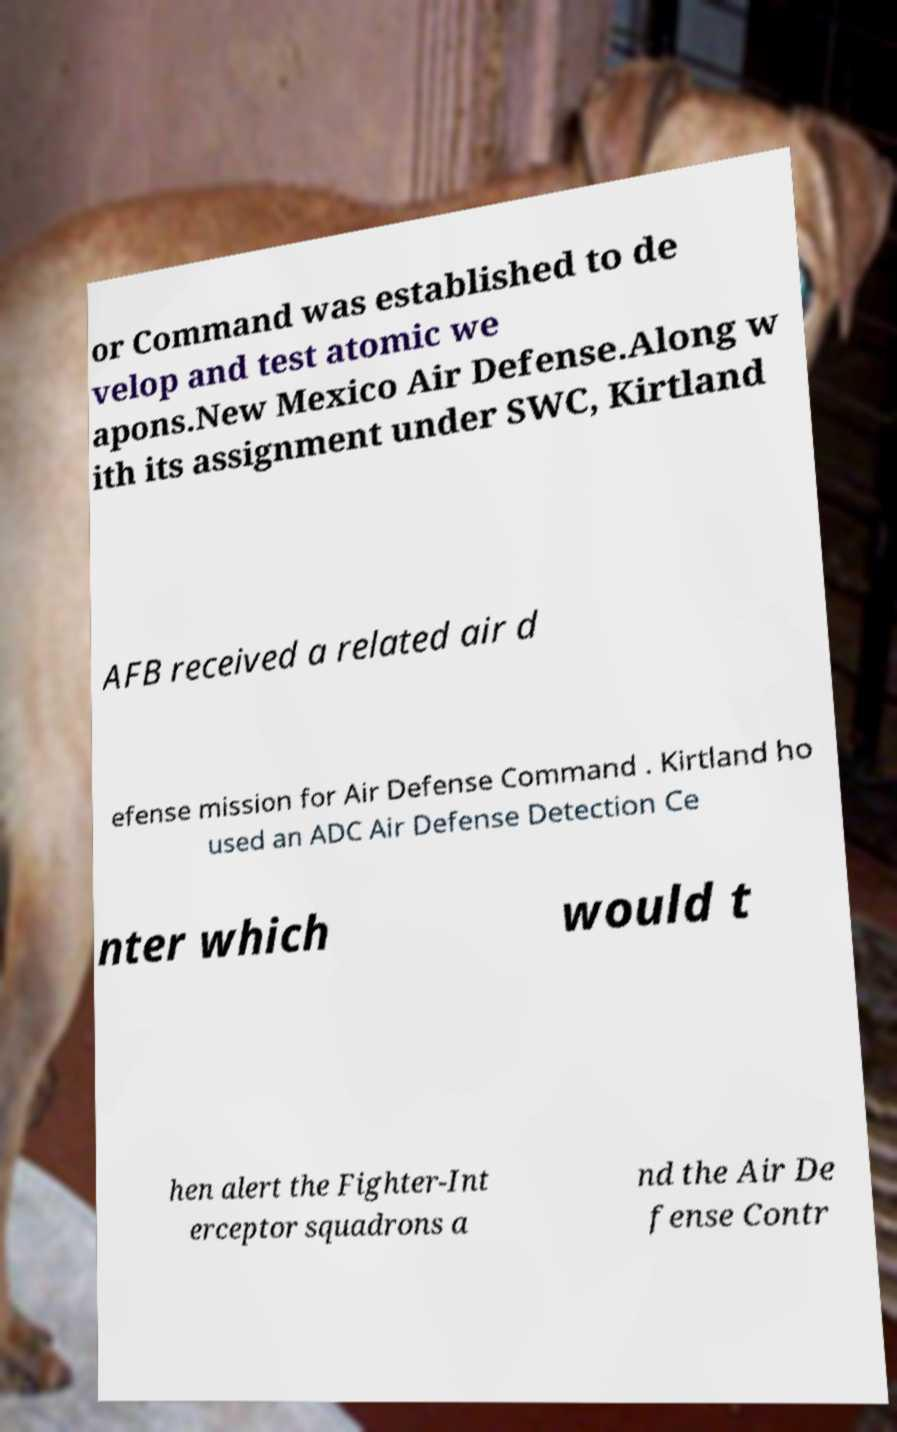Could you assist in decoding the text presented in this image and type it out clearly? or Command was established to de velop and test atomic we apons.New Mexico Air Defense.Along w ith its assignment under SWC, Kirtland AFB received a related air d efense mission for Air Defense Command . Kirtland ho used an ADC Air Defense Detection Ce nter which would t hen alert the Fighter-Int erceptor squadrons a nd the Air De fense Contr 